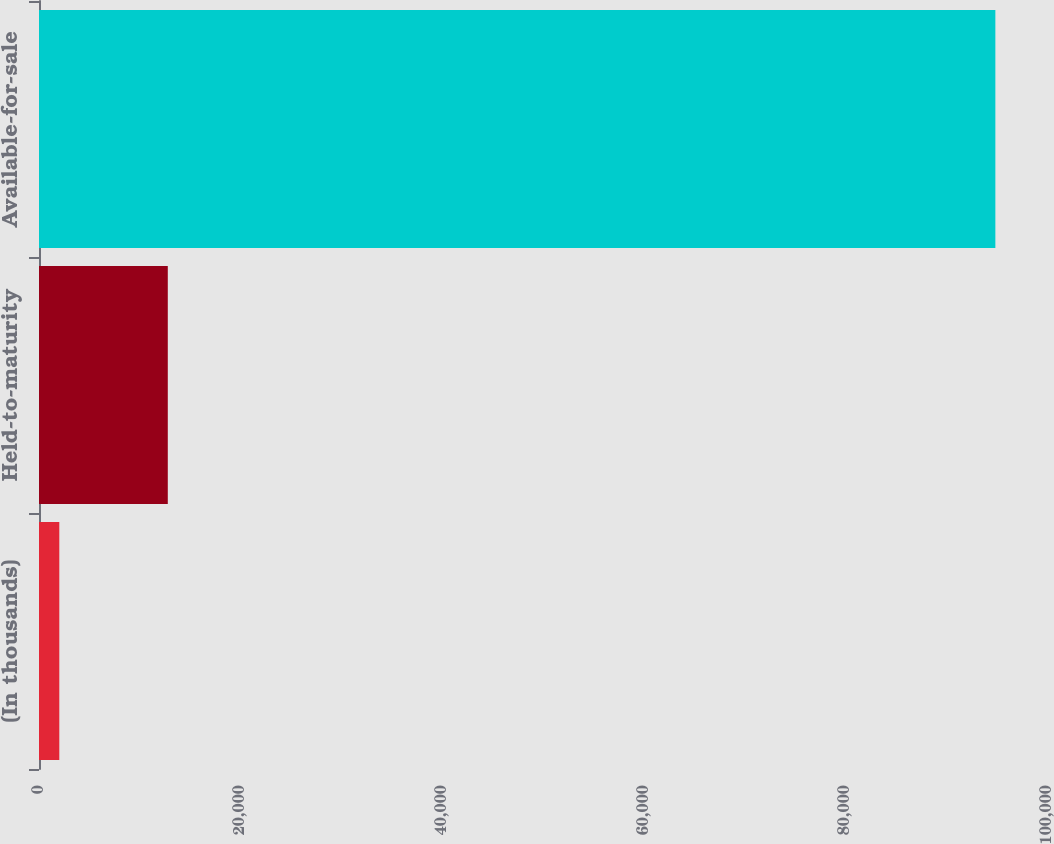<chart> <loc_0><loc_0><loc_500><loc_500><bar_chart><fcel>(In thousands)<fcel>Held-to-maturity<fcel>Available-for-sale<nl><fcel>2015<fcel>12777<fcel>94877<nl></chart> 